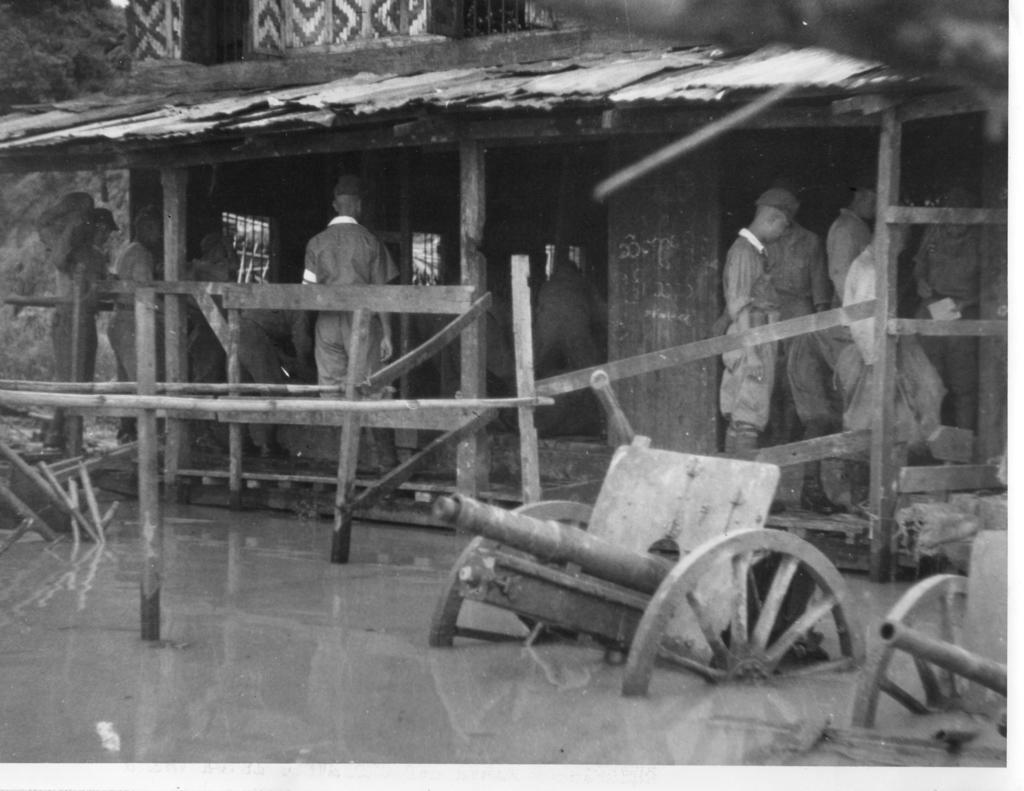In one or two sentences, can you explain what this image depicts? In this image I can see few vehicles in the water, background I can see few persons standing and I can also see the building. In front I can see few wooden sticks and the image is in black and white. 